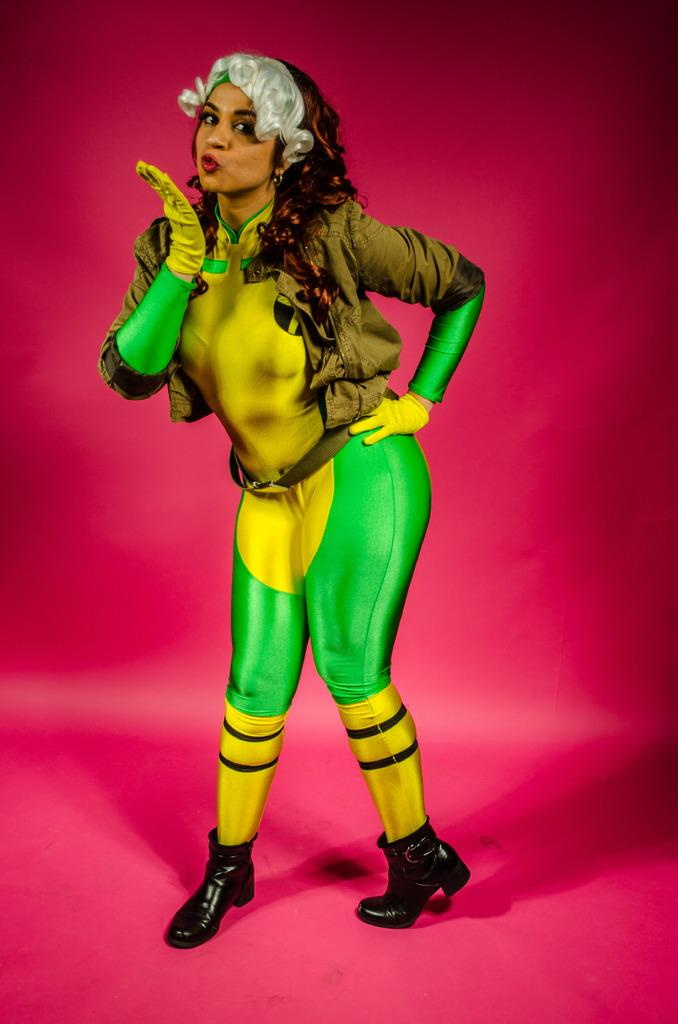Who is the main subject in the image? There is a lady in the image. What can be seen in the background of the image? The background of the image is pink in color. Reasoning: Let' Let's think step by step in order to produce the conversation. We start by identifying the main subject in the image, which is the lady. Then, we describe the background of the image, which is pink. We avoid asking questions that cannot be answered definitively with the given facts and ensure that the language is simple and clear. Absurd Question/Answer: How many birds are flying over the earth in the image? There are no birds or earth visible in the image; it only features a lady and a pink background. What type of powder is being used by the lady in the image? There is no indication of any powder being used by the lady in the image. 